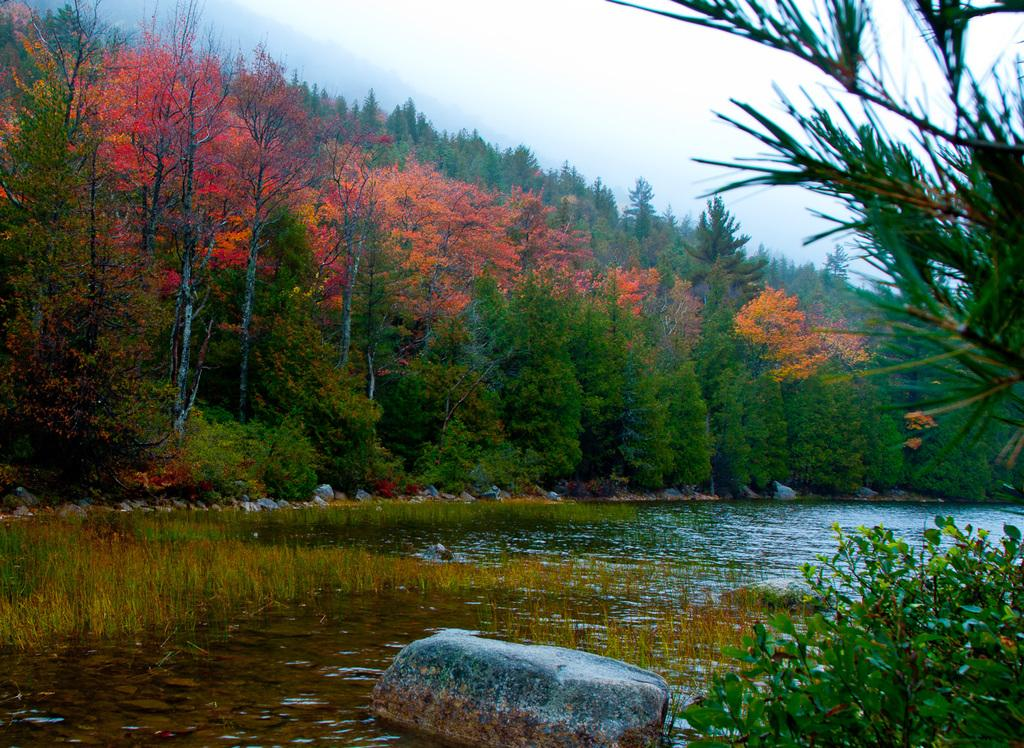Where was the picture taken? The picture was clicked outside the city. What can be seen in the foreground of the image? In the foreground of the image, there are plants, a rock, and a water body. What is visible in the background of the image? In the background of the image, there are plants, trees, and the sky. What type of bread can be seen in the image? There is no bread present in the image. What is the comfort level of the range in the image? There is no range or comfort level mentioned in the image. 